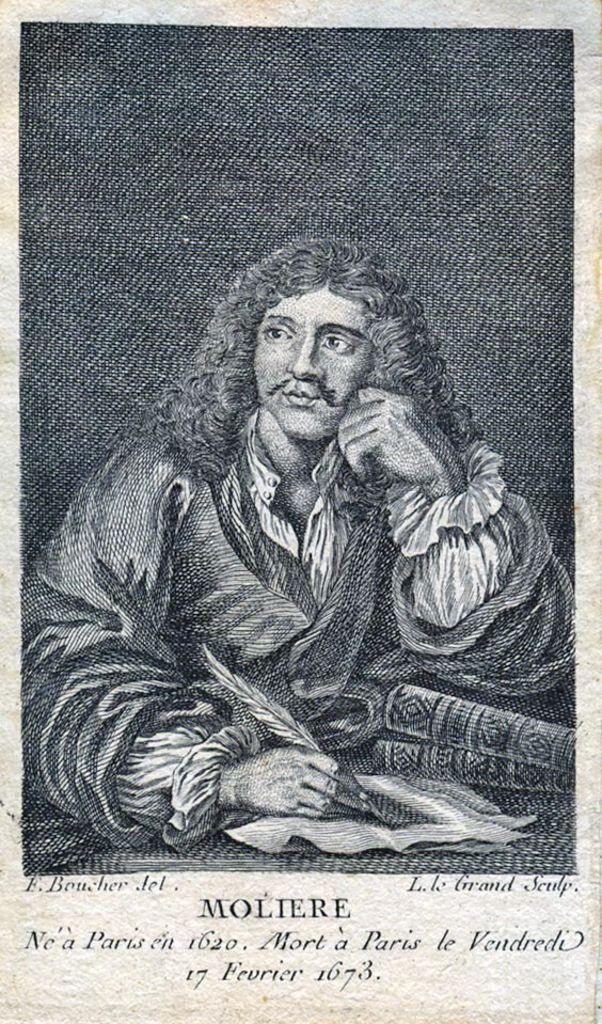What is the color scheme of the image? The image is black and white. What is the man in the image doing? The man is sitting and writing on a paper. Can you describe any other objects in the image? There is a leaf in the image. What is below the man in the image? There is text below the man. What type of sock is the man wearing in the image? There is no sock visible in the image, as it is black and white and does not show any clothing details. 